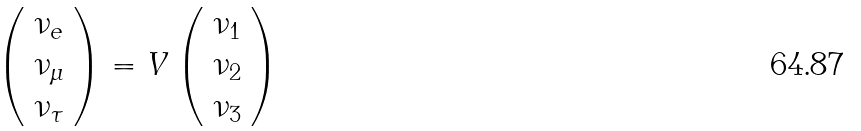Convert formula to latex. <formula><loc_0><loc_0><loc_500><loc_500>\left ( \begin{array} { l } \nu _ { e } \\ \nu _ { \mu } \\ \nu _ { \tau } \end{array} \right ) = V \left ( \begin{array} { l } \nu _ { 1 } \\ \nu _ { 2 } \\ \nu _ { 3 } \end{array} \right )</formula> 